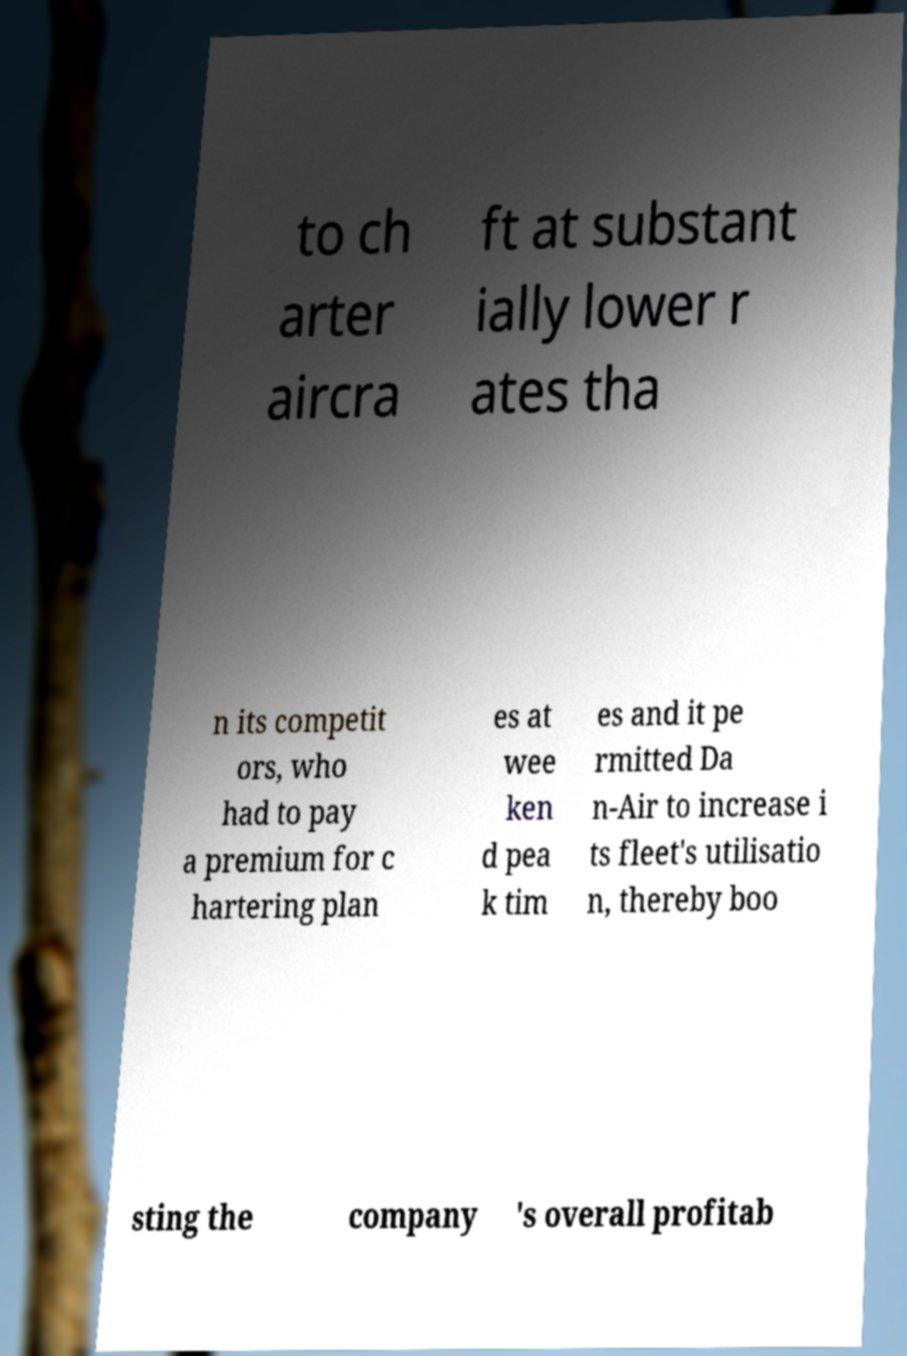Please read and relay the text visible in this image. What does it say? to ch arter aircra ft at substant ially lower r ates tha n its competit ors, who had to pay a premium for c hartering plan es at wee ken d pea k tim es and it pe rmitted Da n-Air to increase i ts fleet's utilisatio n, thereby boo sting the company 's overall profitab 